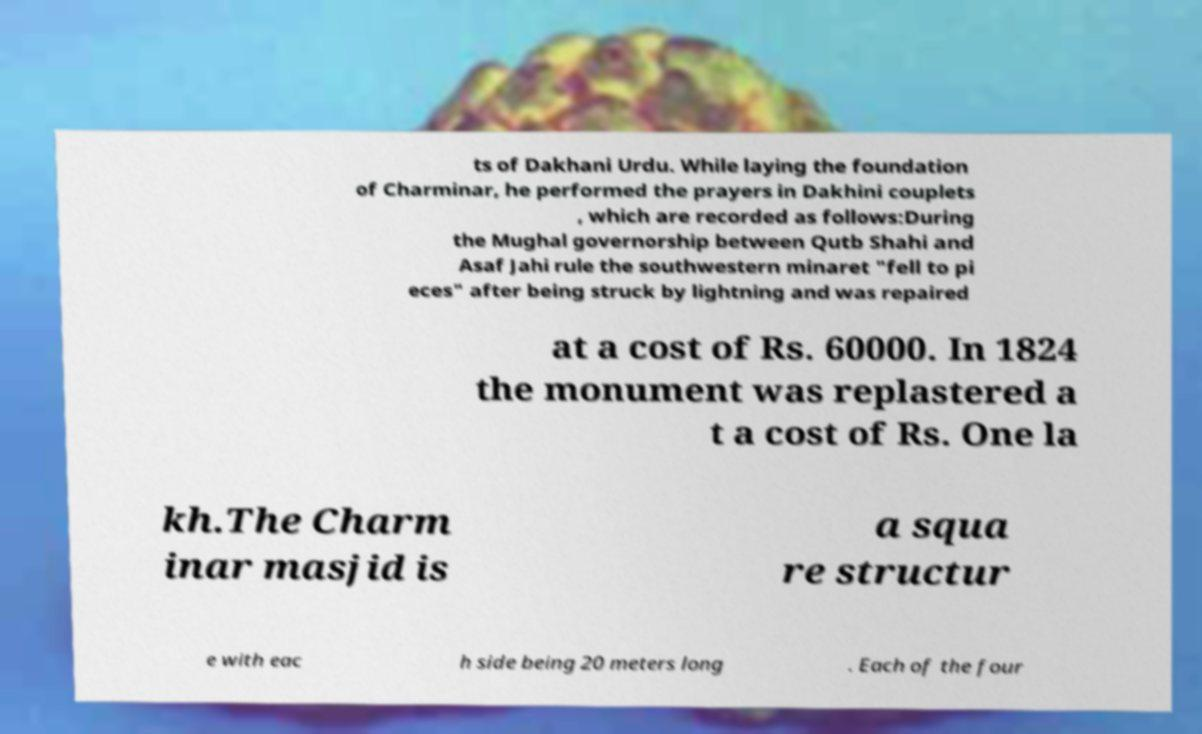For documentation purposes, I need the text within this image transcribed. Could you provide that? ts of Dakhani Urdu. While laying the foundation of Charminar, he performed the prayers in Dakhini couplets , which are recorded as follows:During the Mughal governorship between Qutb Shahi and Asaf Jahi rule the southwestern minaret "fell to pi eces" after being struck by lightning and was repaired at a cost of Rs. 60000. In 1824 the monument was replastered a t a cost of Rs. One la kh.The Charm inar masjid is a squa re structur e with eac h side being 20 meters long . Each of the four 